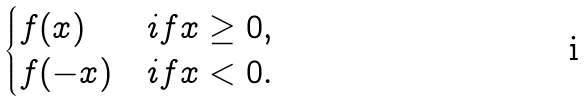<formula> <loc_0><loc_0><loc_500><loc_500>\begin{cases} f ( x ) & i f x \geq 0 , \\ f ( - x ) & i f x < 0 . \end{cases}</formula> 